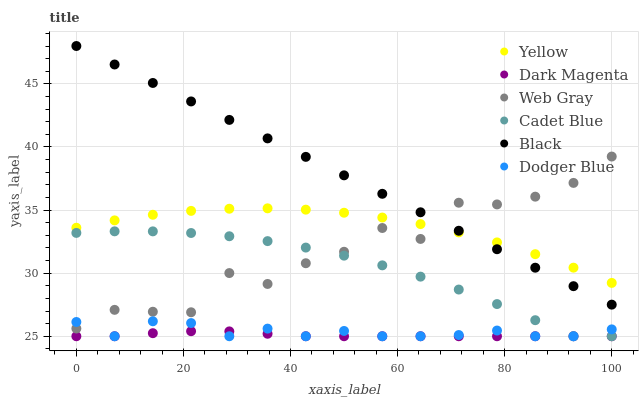Does Dark Magenta have the minimum area under the curve?
Answer yes or no. Yes. Does Black have the maximum area under the curve?
Answer yes or no. Yes. Does Yellow have the minimum area under the curve?
Answer yes or no. No. Does Yellow have the maximum area under the curve?
Answer yes or no. No. Is Black the smoothest?
Answer yes or no. Yes. Is Web Gray the roughest?
Answer yes or no. Yes. Is Dark Magenta the smoothest?
Answer yes or no. No. Is Dark Magenta the roughest?
Answer yes or no. No. Does Cadet Blue have the lowest value?
Answer yes or no. Yes. Does Yellow have the lowest value?
Answer yes or no. No. Does Black have the highest value?
Answer yes or no. Yes. Does Yellow have the highest value?
Answer yes or no. No. Is Dark Magenta less than Yellow?
Answer yes or no. Yes. Is Black greater than Dark Magenta?
Answer yes or no. Yes. Does Dark Magenta intersect Cadet Blue?
Answer yes or no. Yes. Is Dark Magenta less than Cadet Blue?
Answer yes or no. No. Is Dark Magenta greater than Cadet Blue?
Answer yes or no. No. Does Dark Magenta intersect Yellow?
Answer yes or no. No. 